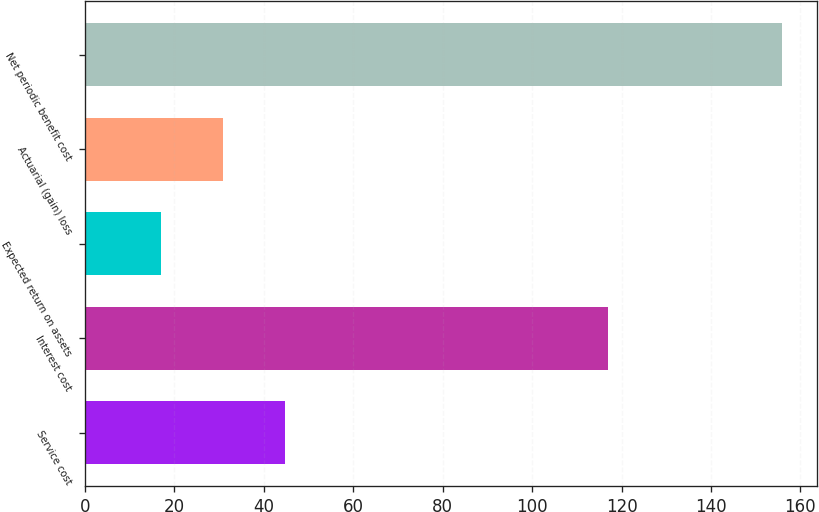<chart> <loc_0><loc_0><loc_500><loc_500><bar_chart><fcel>Service cost<fcel>Interest cost<fcel>Expected return on assets<fcel>Actuarial (gain) loss<fcel>Net periodic benefit cost<nl><fcel>44.8<fcel>117<fcel>17<fcel>30.9<fcel>156<nl></chart> 